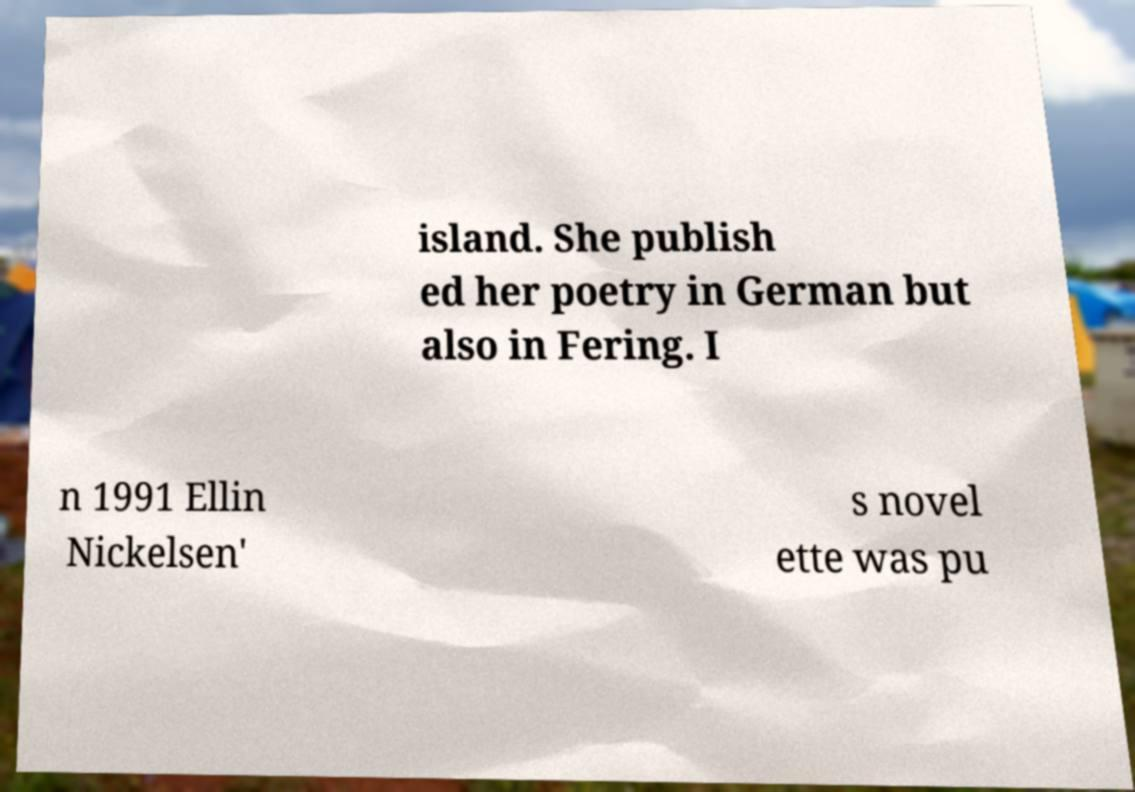There's text embedded in this image that I need extracted. Can you transcribe it verbatim? island. She publish ed her poetry in German but also in Fering. I n 1991 Ellin Nickelsen' s novel ette was pu 